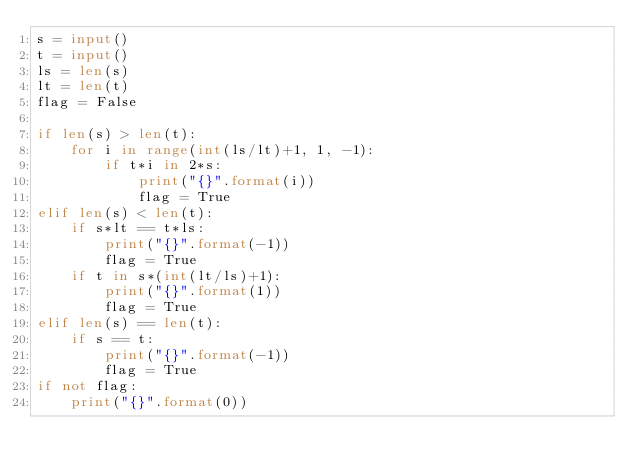<code> <loc_0><loc_0><loc_500><loc_500><_Python_>s = input()
t = input()
ls = len(s)
lt = len(t)
flag = False

if len(s) > len(t):
    for i in range(int(ls/lt)+1, 1, -1):
        if t*i in 2*s:
            print("{}".format(i))
            flag = True
elif len(s) < len(t):
    if s*lt == t*ls:
        print("{}".format(-1))
        flag = True
    if t in s*(int(lt/ls)+1):
        print("{}".format(1))
        flag = True
elif len(s) == len(t):
    if s == t:
        print("{}".format(-1))
        flag = True
if not flag:
    print("{}".format(0))</code> 